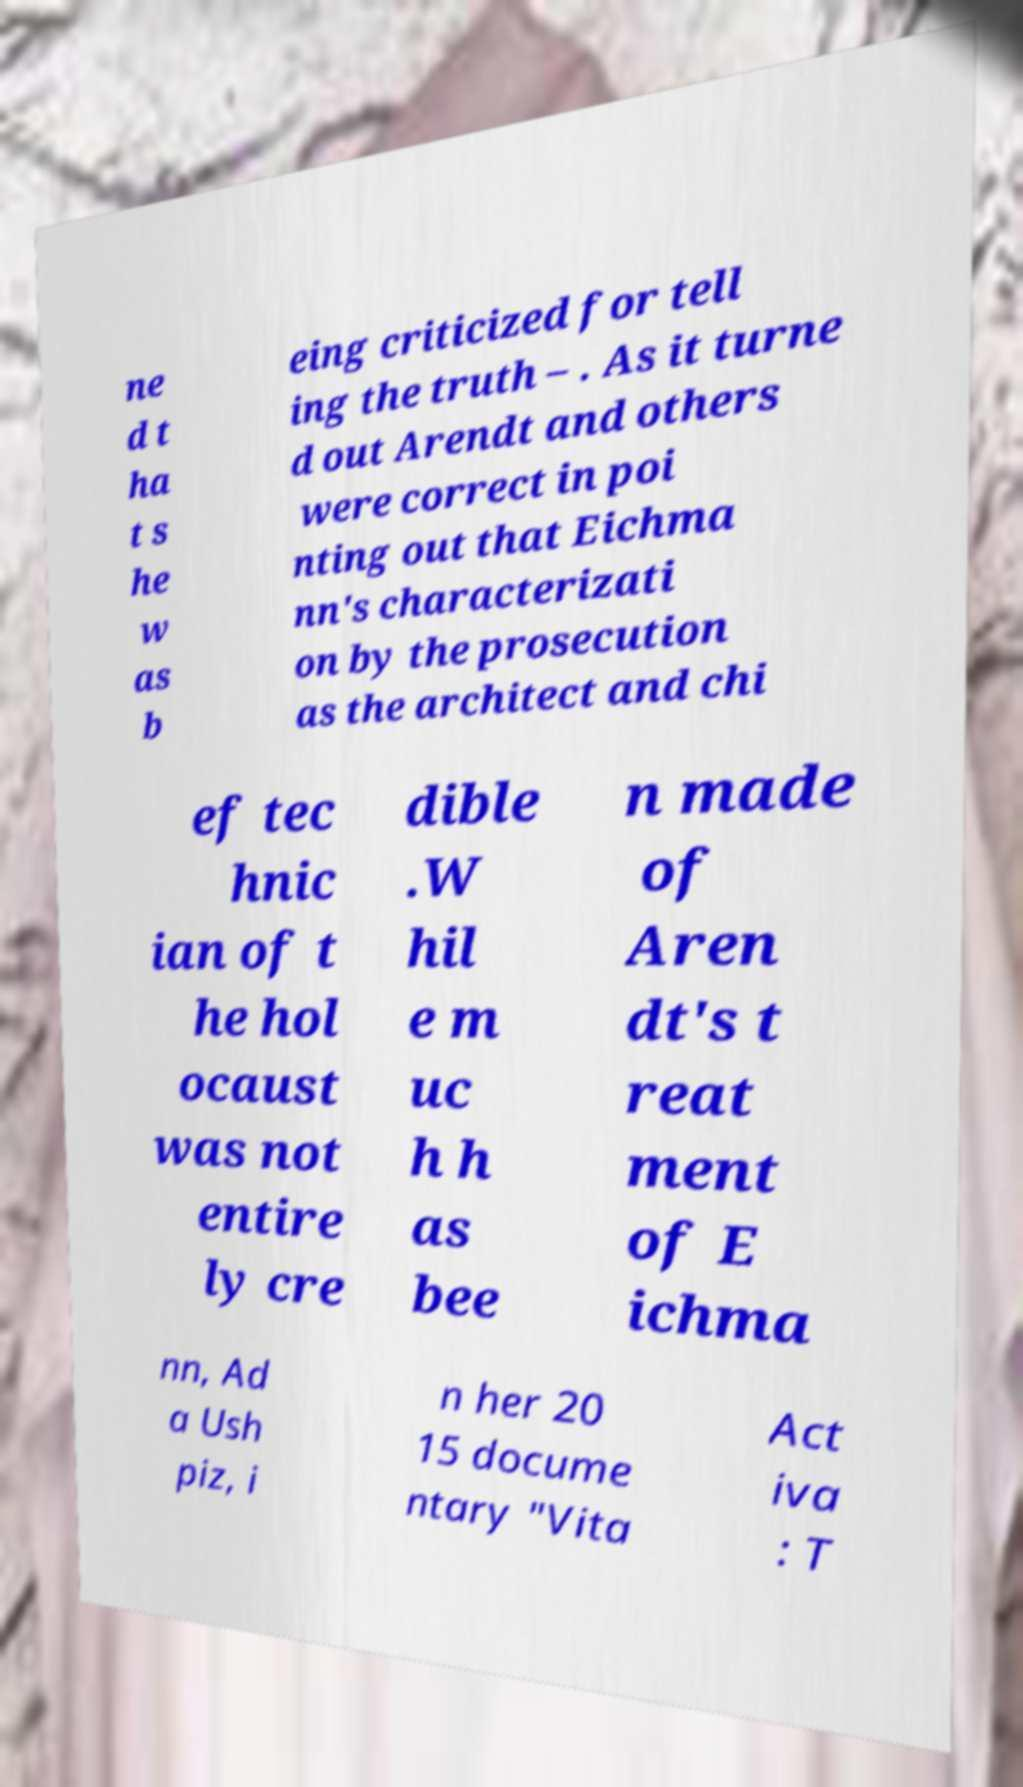Could you assist in decoding the text presented in this image and type it out clearly? ne d t ha t s he w as b eing criticized for tell ing the truth – . As it turne d out Arendt and others were correct in poi nting out that Eichma nn's characterizati on by the prosecution as the architect and chi ef tec hnic ian of t he hol ocaust was not entire ly cre dible .W hil e m uc h h as bee n made of Aren dt's t reat ment of E ichma nn, Ad a Ush piz, i n her 20 15 docume ntary "Vita Act iva : T 